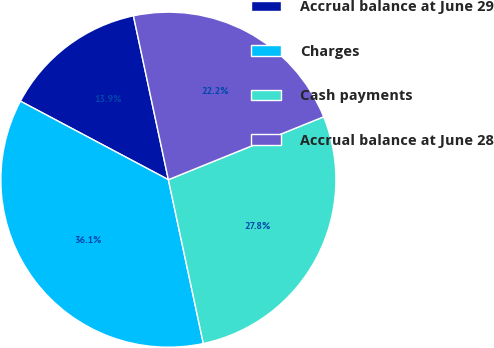Convert chart. <chart><loc_0><loc_0><loc_500><loc_500><pie_chart><fcel>Accrual balance at June 29<fcel>Charges<fcel>Cash payments<fcel>Accrual balance at June 28<nl><fcel>13.89%<fcel>36.11%<fcel>27.78%<fcel>22.22%<nl></chart> 